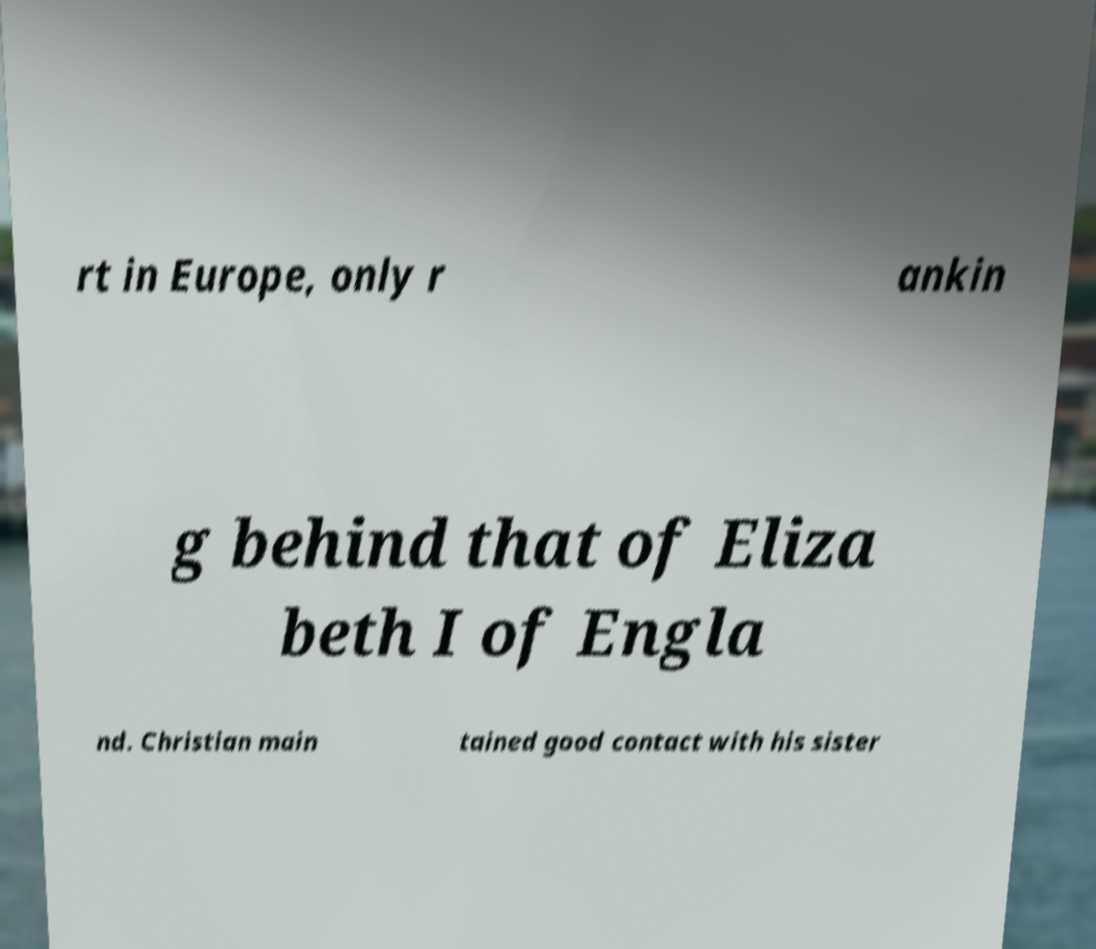Could you assist in decoding the text presented in this image and type it out clearly? rt in Europe, only r ankin g behind that of Eliza beth I of Engla nd. Christian main tained good contact with his sister 